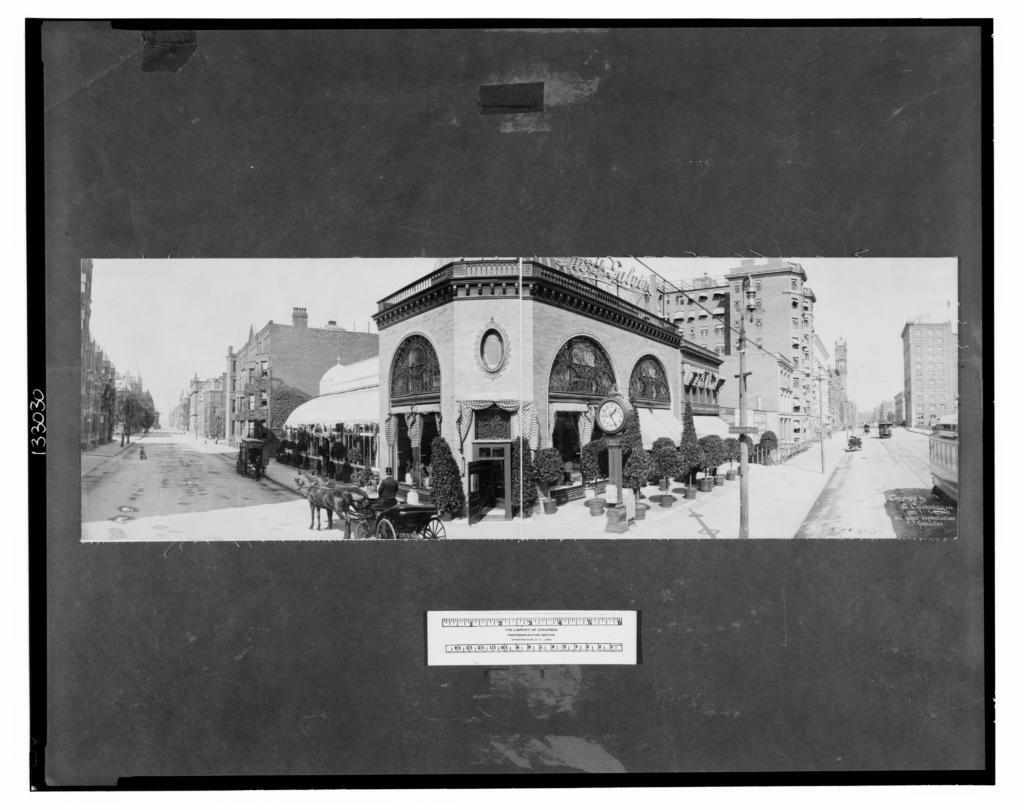In one or two sentences, can you explain what this image depicts? This is a black and white image where we can see buildings, trees, poles, wires, vehicles moving on the road, horse cart and the sky in the background. 